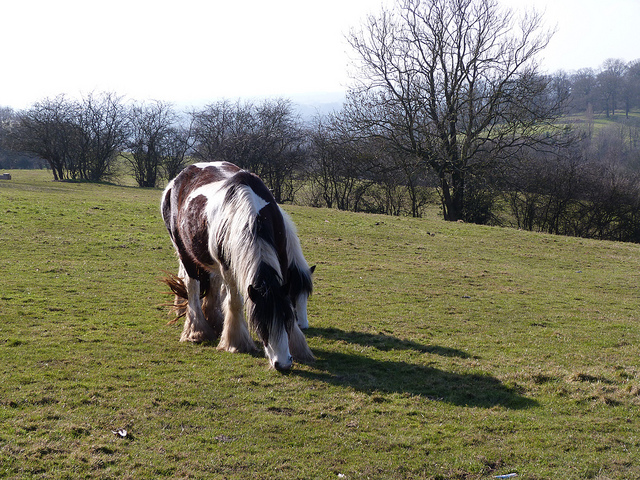Are they out in a pasture? Yes, the horse is out in a pasture, surrounded by open fields and distant trees, indicating a natural and spacious setting. 